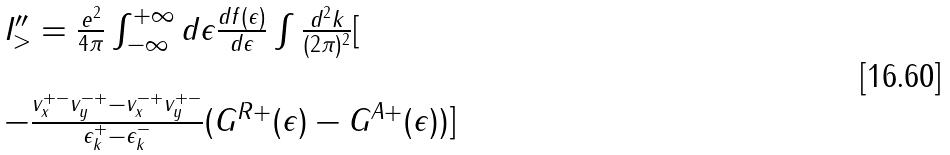Convert formula to latex. <formula><loc_0><loc_0><loc_500><loc_500>\begin{array} { l } I _ { > } ^ { \prime \prime } = \frac { e ^ { 2 } } { 4 \pi } \int _ { - \infty } ^ { + \infty } d \epsilon \frac { d f ( \epsilon ) } { d \epsilon } \int \frac { d ^ { 2 } { k } } { ( 2 \pi ) ^ { 2 } } [ \\ \\ - \frac { v _ { x } ^ { + - } v _ { y } ^ { - + } - v _ { x } ^ { - + } v _ { y } ^ { + - } } { \epsilon ^ { + } _ { k } - \epsilon ^ { - } _ { k } } ( G ^ { R + } ( \epsilon ) - G ^ { A + } ( \epsilon ) ) ] \end{array}</formula> 